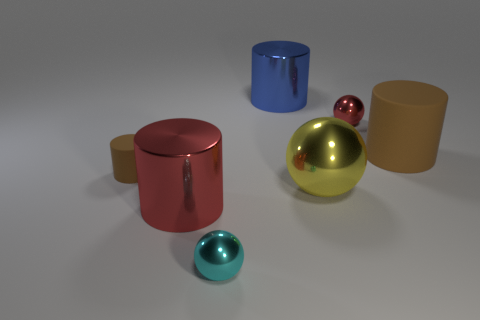Subtract all yellow balls. How many brown cylinders are left? 2 Add 1 large cylinders. How many objects exist? 8 Subtract all blue cylinders. How many cylinders are left? 3 Subtract all big blue shiny cylinders. How many cylinders are left? 3 Subtract all purple balls. Subtract all blue cylinders. How many balls are left? 3 Subtract all cylinders. How many objects are left? 3 Add 4 large brown cylinders. How many large brown cylinders exist? 5 Subtract 0 green spheres. How many objects are left? 7 Subtract all small yellow metallic balls. Subtract all yellow metal things. How many objects are left? 6 Add 3 metallic things. How many metallic things are left? 8 